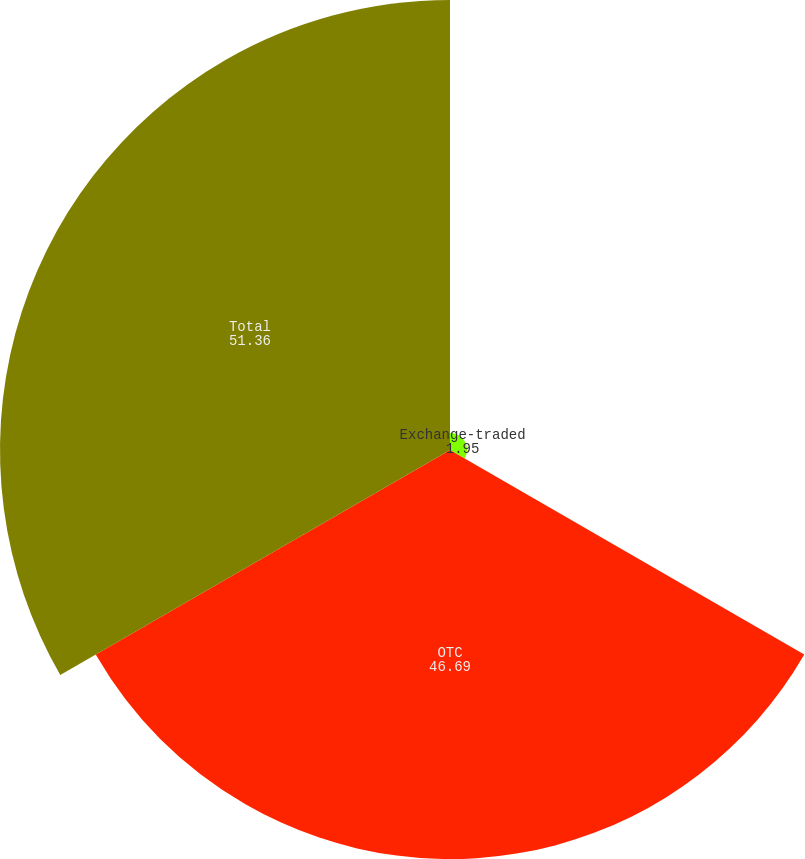Convert chart to OTSL. <chart><loc_0><loc_0><loc_500><loc_500><pie_chart><fcel>Exchange-traded<fcel>OTC<fcel>Total<nl><fcel>1.95%<fcel>46.69%<fcel>51.36%<nl></chart> 